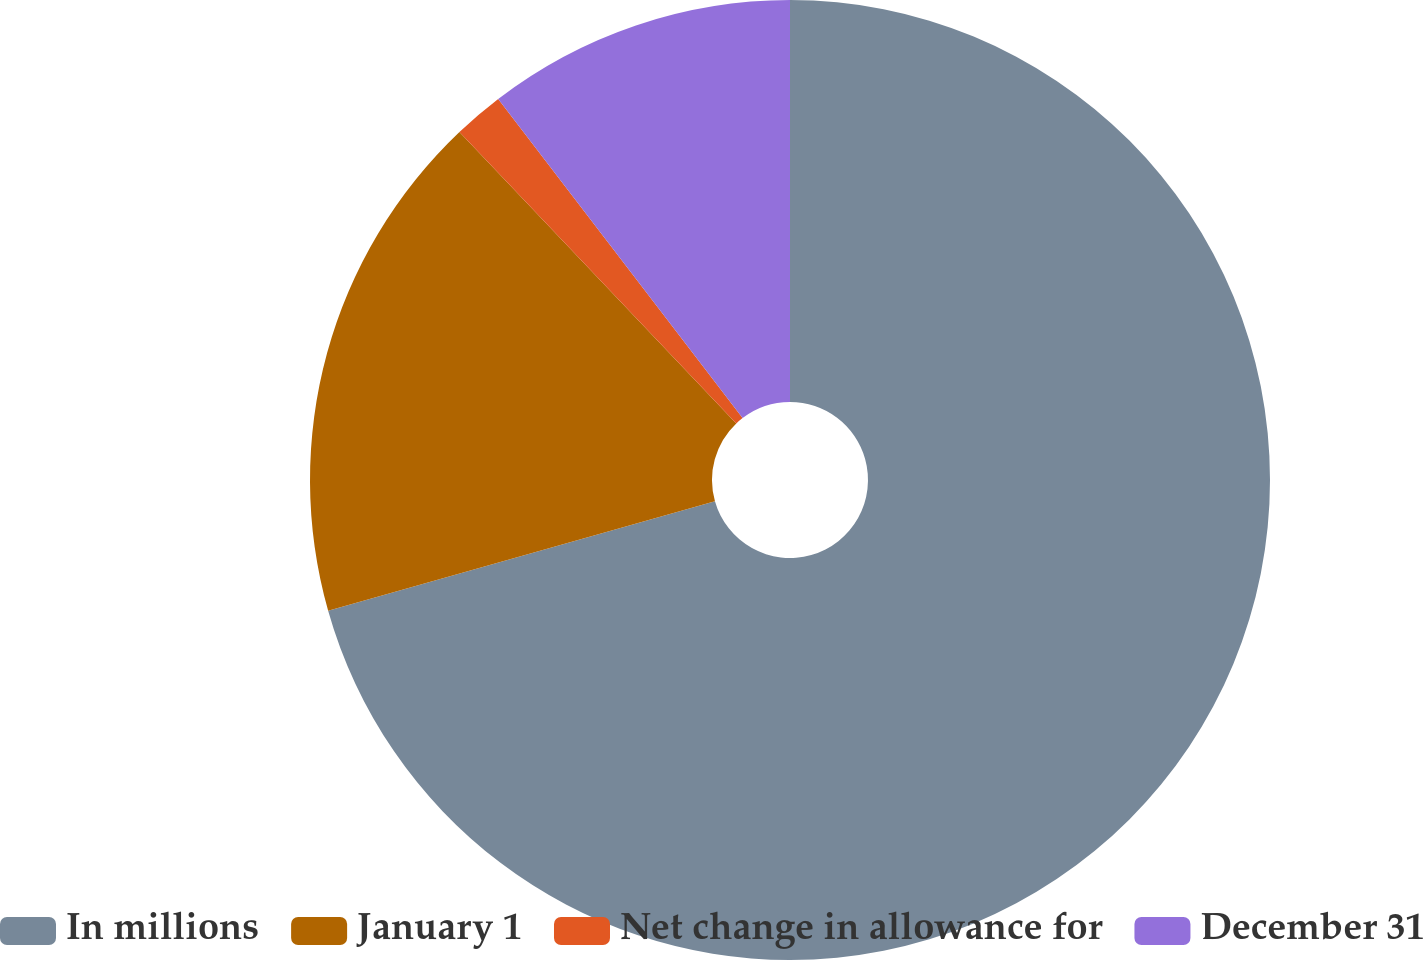Convert chart to OTSL. <chart><loc_0><loc_0><loc_500><loc_500><pie_chart><fcel>In millions<fcel>January 1<fcel>Net change in allowance for<fcel>December 31<nl><fcel>70.61%<fcel>17.3%<fcel>1.69%<fcel>10.4%<nl></chart> 